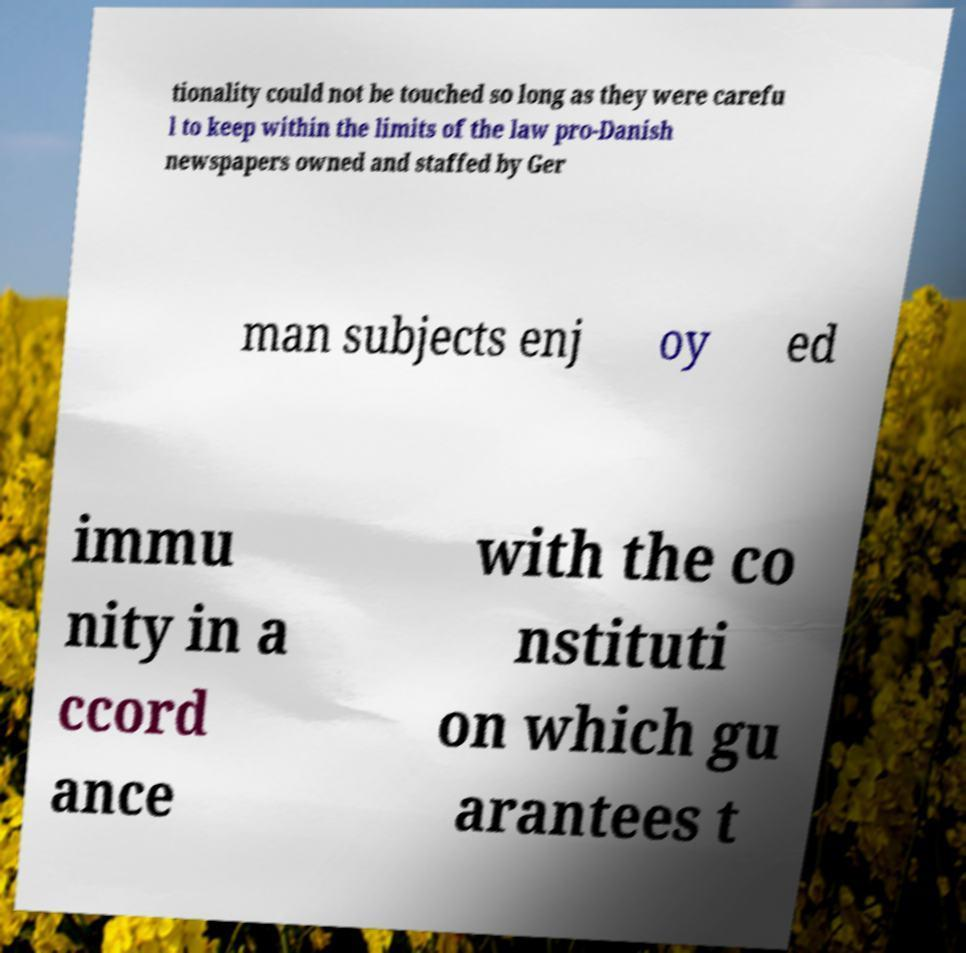Can you read and provide the text displayed in the image?This photo seems to have some interesting text. Can you extract and type it out for me? tionality could not be touched so long as they were carefu l to keep within the limits of the law pro-Danish newspapers owned and staffed by Ger man subjects enj oy ed immu nity in a ccord ance with the co nstituti on which gu arantees t 